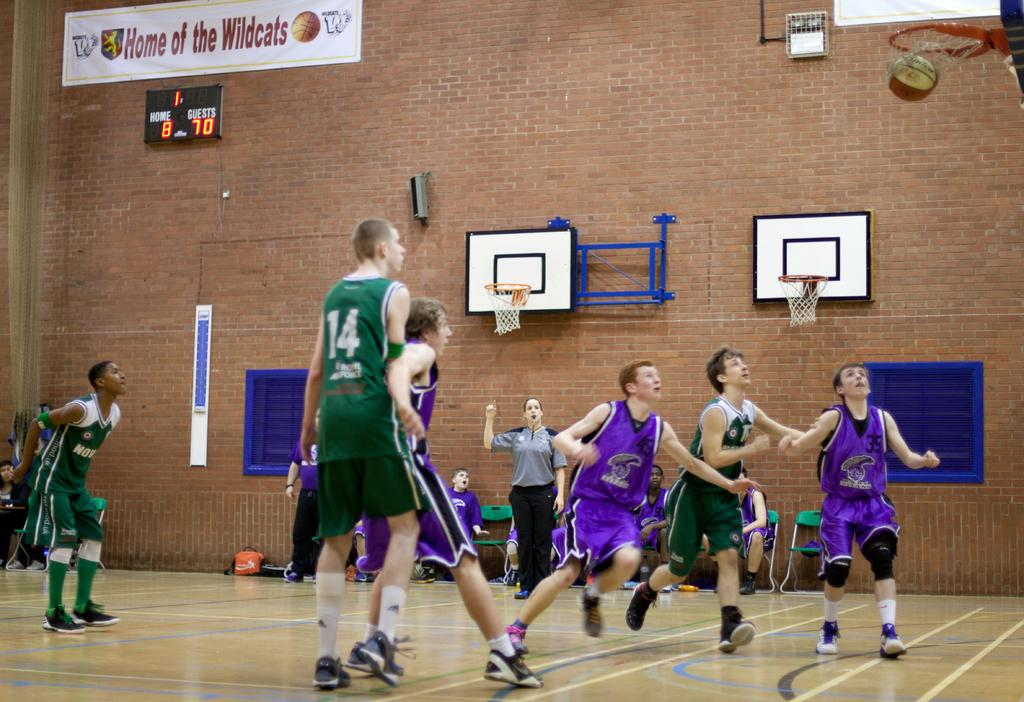What activity are the boys engaged in within the image? The boys are playing basketball in the image. What can be seen in the background of the image? There is a brick wall in the background of the image. What type of thought can be seen floating above the boys' heads in the image? There is no thought visible in the image; it only shows the boys playing basketball and the brick wall in the background. 